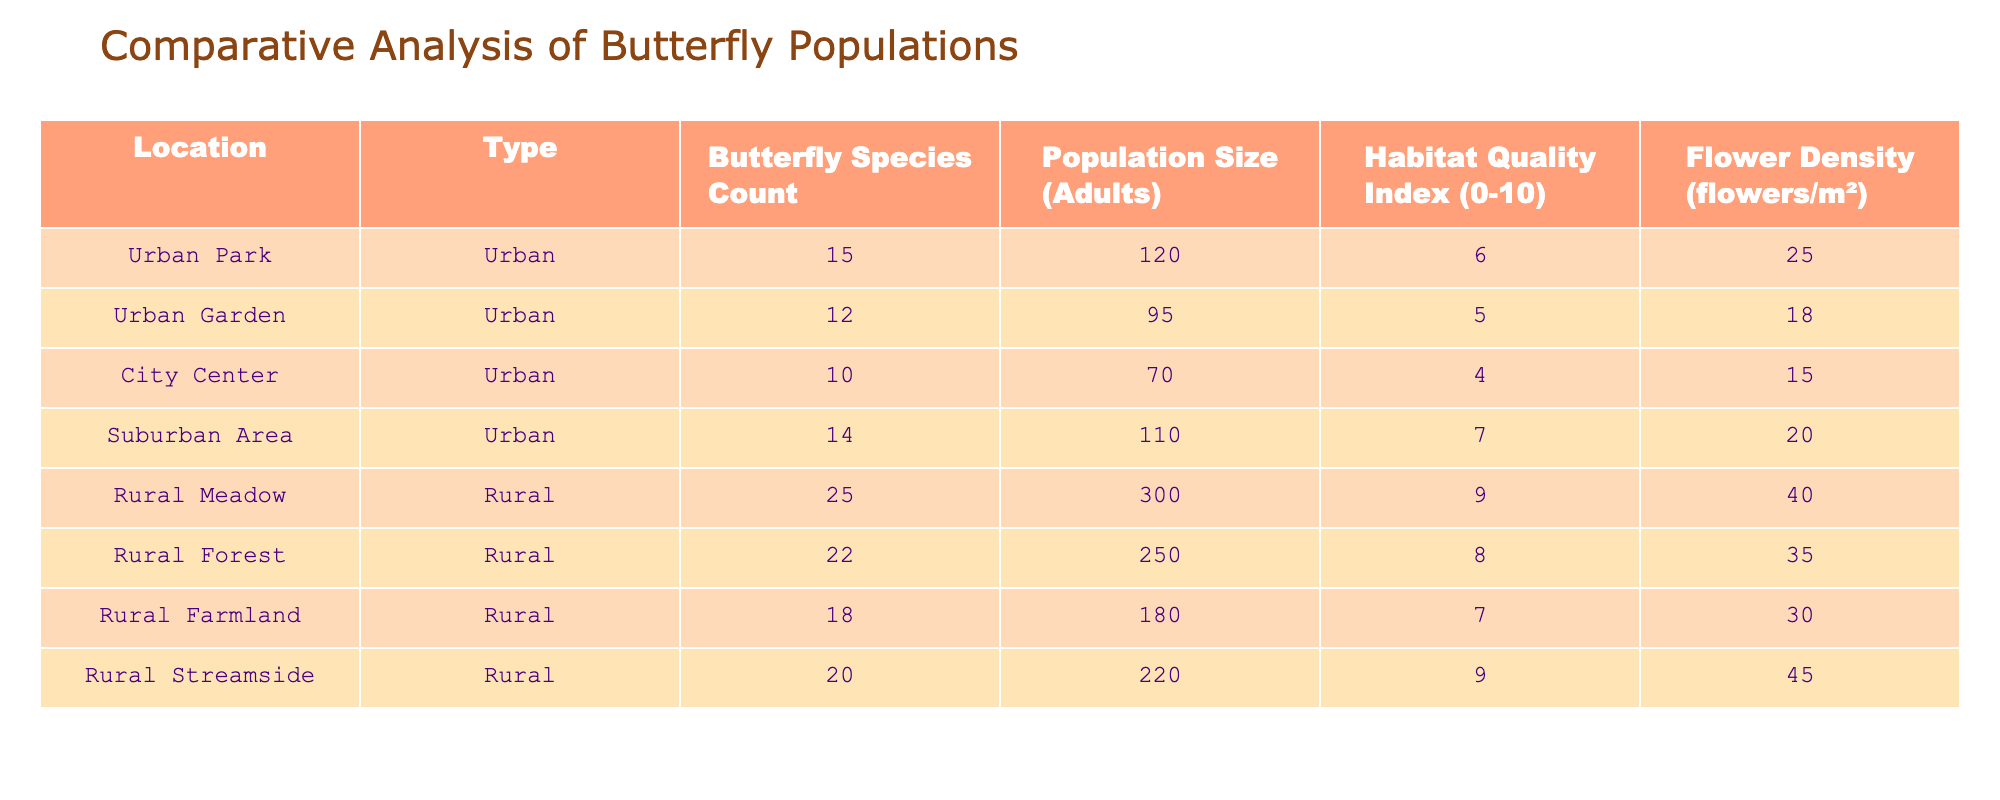What is the butterfly species count in the Rural Meadow? The Rural Meadow row in the table shows a butterfly species count of 25.
Answer: 25 What is the population size of butterflies in the City Center? The population size for the City Center listed in the table is 70 adults.
Answer: 70 Which location has the highest habitat quality index? By comparing the Habitat Quality Index values, the Rural Meadow has the highest index of 9.
Answer: Rural Meadow Is the total butterfly population size in rural areas greater than urban areas? The total population size for rural areas is 300 + 250 + 180 + 220 = 950. The urban areas total is 120 + 95 + 70 + 110 = 395. Since 950 > 395, the answer is yes.
Answer: Yes What is the average flower density in urban locations? The flower densities for urban locations are 25, 18, 15, and 20. Adding these gives 25 + 18 + 15 + 20 = 78. There are 4 urban locations, so the average is 78 / 4 = 19.5.
Answer: 19.5 Which rural location has the lowest butterfly species count? The rural locations have species counts of 25, 22, 18, and 20. The lowest among these is 18, which corresponds to the Rural Farmland.
Answer: Rural Farmland How many more adults are there in the Rural Streamside compared to the Urban Garden? The population size for the Rural Streamside is 220 and for the Urban Garden, it is 95. The difference is 220 - 95 = 125.
Answer: 125 Is there any urban area with a flower density greater than 20? The flower densities for urban areas are 25, 18, 15, and 20. Only the Urban Park has a density of 25, which is greater than 20. Therefore, the answer is yes.
Answer: Yes What is the sum of the habitat quality index for all locations? The habitat quality indices are 6, 5, 4, 7, 9, 8, 7, and 9. Adding these gives 6 + 5 + 4 + 7 + 9 + 8 + 7 + 9 = 55.
Answer: 55 